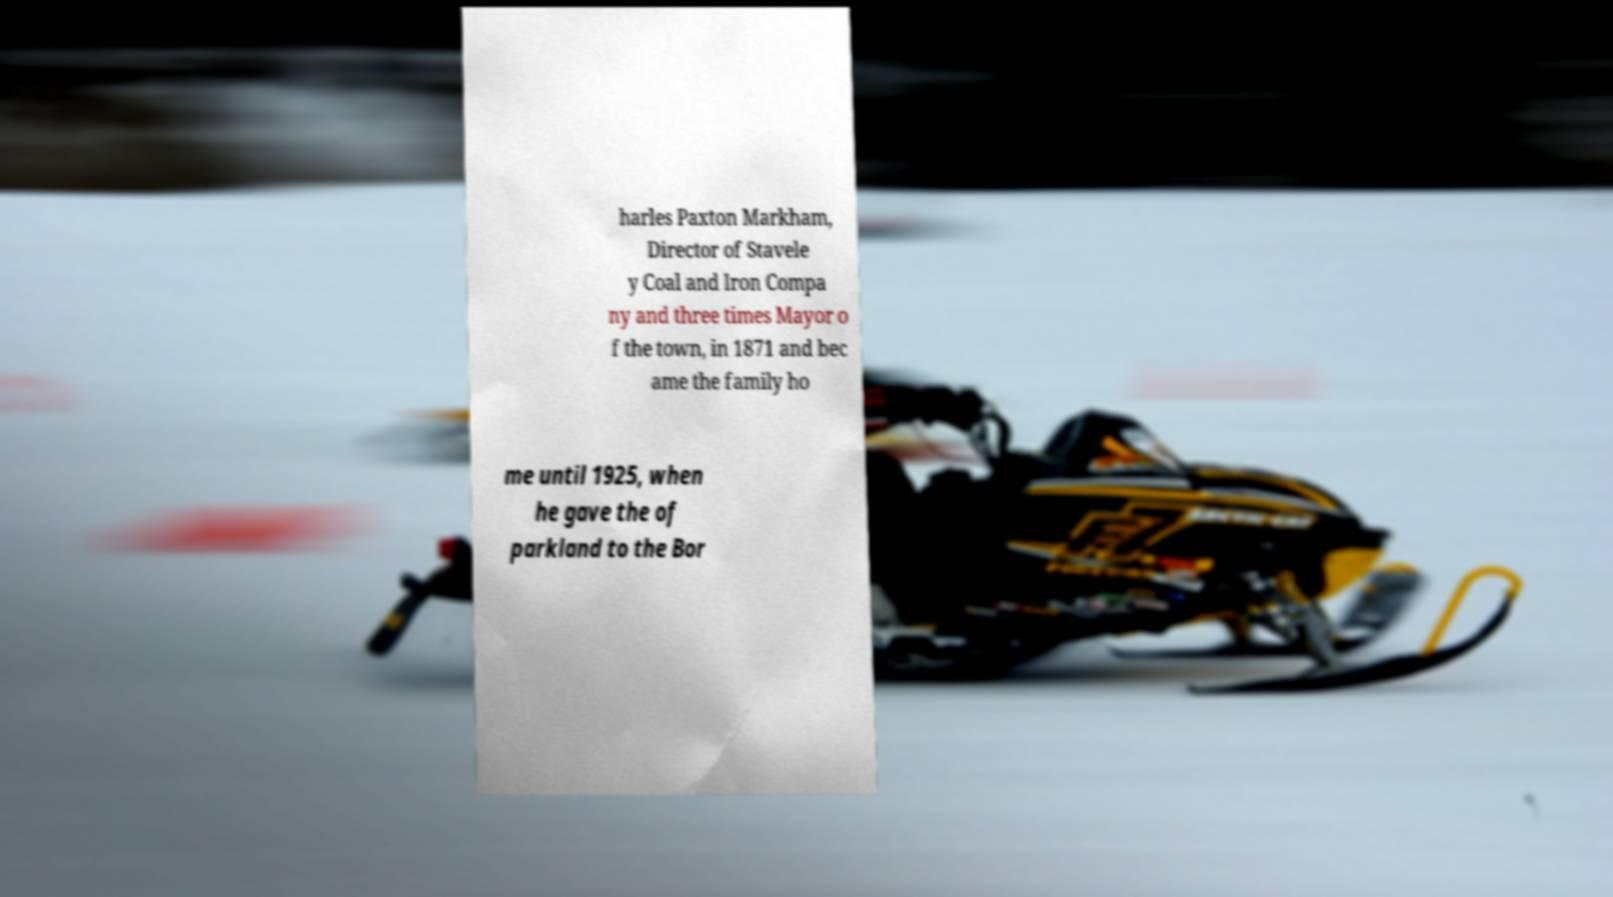I need the written content from this picture converted into text. Can you do that? harles Paxton Markham, Director of Stavele y Coal and Iron Compa ny and three times Mayor o f the town, in 1871 and bec ame the family ho me until 1925, when he gave the of parkland to the Bor 